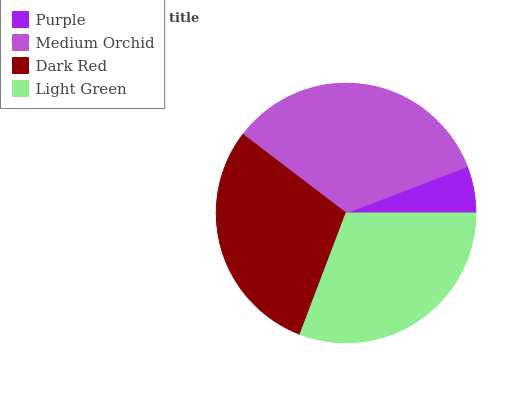Is Purple the minimum?
Answer yes or no. Yes. Is Medium Orchid the maximum?
Answer yes or no. Yes. Is Dark Red the minimum?
Answer yes or no. No. Is Dark Red the maximum?
Answer yes or no. No. Is Medium Orchid greater than Dark Red?
Answer yes or no. Yes. Is Dark Red less than Medium Orchid?
Answer yes or no. Yes. Is Dark Red greater than Medium Orchid?
Answer yes or no. No. Is Medium Orchid less than Dark Red?
Answer yes or no. No. Is Light Green the high median?
Answer yes or no. Yes. Is Dark Red the low median?
Answer yes or no. Yes. Is Purple the high median?
Answer yes or no. No. Is Light Green the low median?
Answer yes or no. No. 